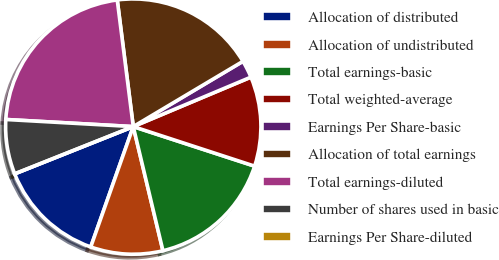Convert chart to OTSL. <chart><loc_0><loc_0><loc_500><loc_500><pie_chart><fcel>Allocation of distributed<fcel>Allocation of undistributed<fcel>Total earnings-basic<fcel>Total weighted-average<fcel>Earnings Per Share-basic<fcel>Allocation of total earnings<fcel>Total earnings-diluted<fcel>Number of shares used in basic<fcel>Earnings Per Share-diluted<nl><fcel>13.56%<fcel>9.14%<fcel>16.25%<fcel>11.35%<fcel>2.21%<fcel>18.46%<fcel>22.11%<fcel>6.92%<fcel>0.0%<nl></chart> 